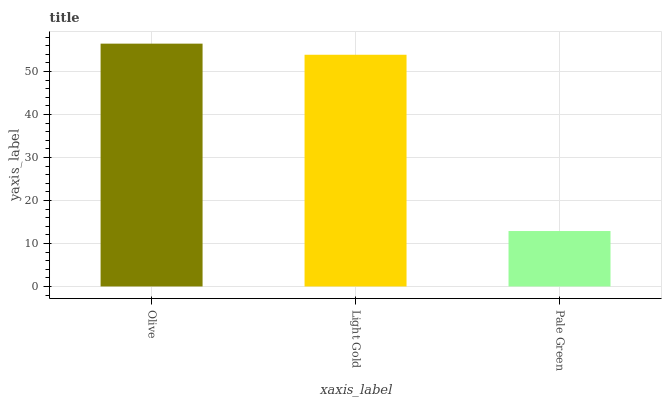Is Pale Green the minimum?
Answer yes or no. Yes. Is Olive the maximum?
Answer yes or no. Yes. Is Light Gold the minimum?
Answer yes or no. No. Is Light Gold the maximum?
Answer yes or no. No. Is Olive greater than Light Gold?
Answer yes or no. Yes. Is Light Gold less than Olive?
Answer yes or no. Yes. Is Light Gold greater than Olive?
Answer yes or no. No. Is Olive less than Light Gold?
Answer yes or no. No. Is Light Gold the high median?
Answer yes or no. Yes. Is Light Gold the low median?
Answer yes or no. Yes. Is Pale Green the high median?
Answer yes or no. No. Is Pale Green the low median?
Answer yes or no. No. 